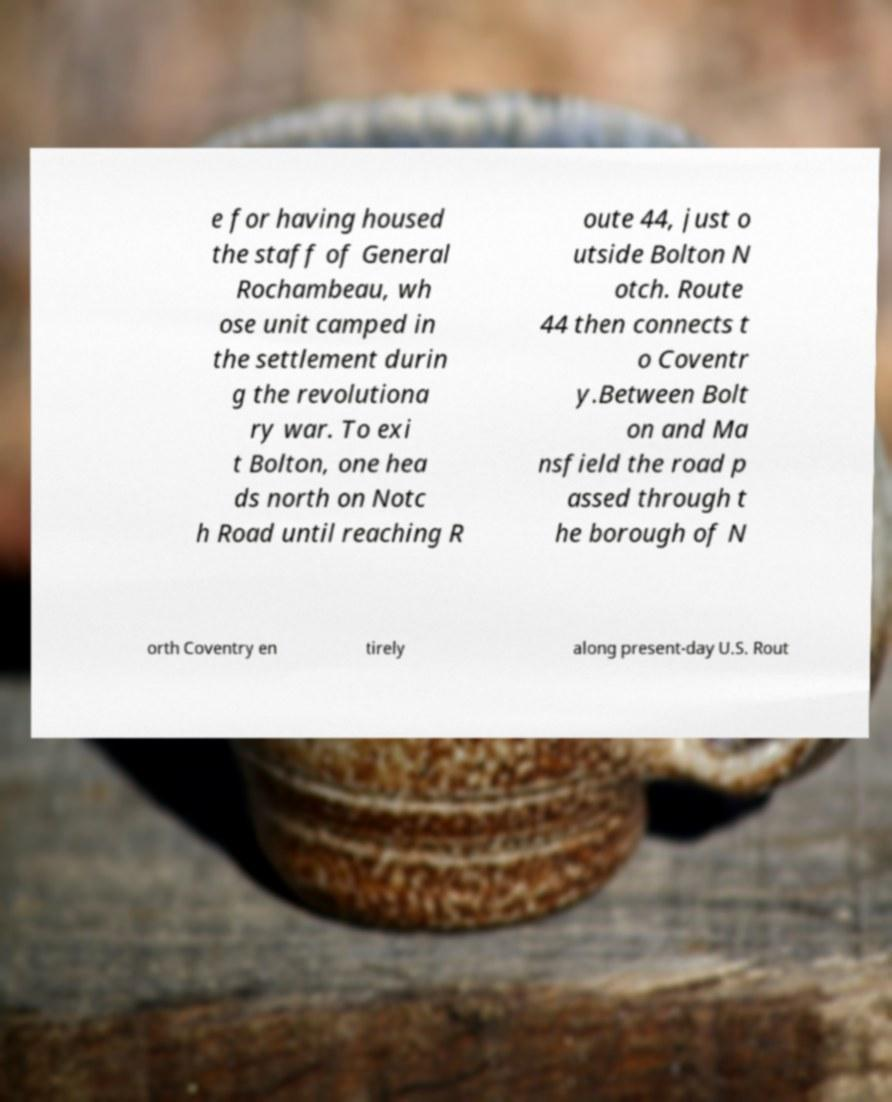Can you accurately transcribe the text from the provided image for me? e for having housed the staff of General Rochambeau, wh ose unit camped in the settlement durin g the revolutiona ry war. To exi t Bolton, one hea ds north on Notc h Road until reaching R oute 44, just o utside Bolton N otch. Route 44 then connects t o Coventr y.Between Bolt on and Ma nsfield the road p assed through t he borough of N orth Coventry en tirely along present-day U.S. Rout 